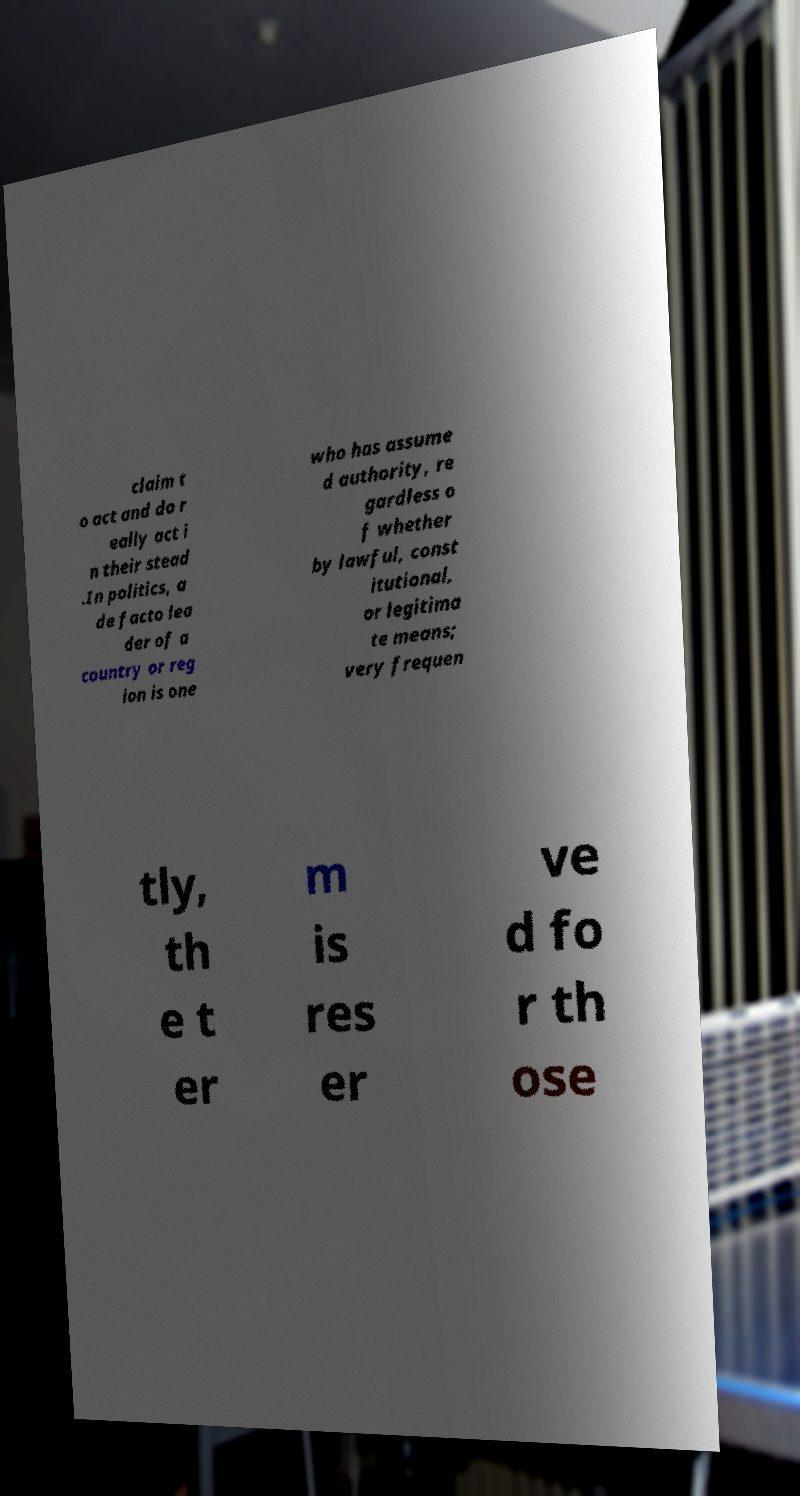There's text embedded in this image that I need extracted. Can you transcribe it verbatim? claim t o act and do r eally act i n their stead .In politics, a de facto lea der of a country or reg ion is one who has assume d authority, re gardless o f whether by lawful, const itutional, or legitima te means; very frequen tly, th e t er m is res er ve d fo r th ose 